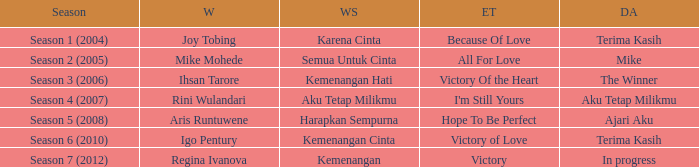Which album debuted in season 2 (2005)? Mike. 